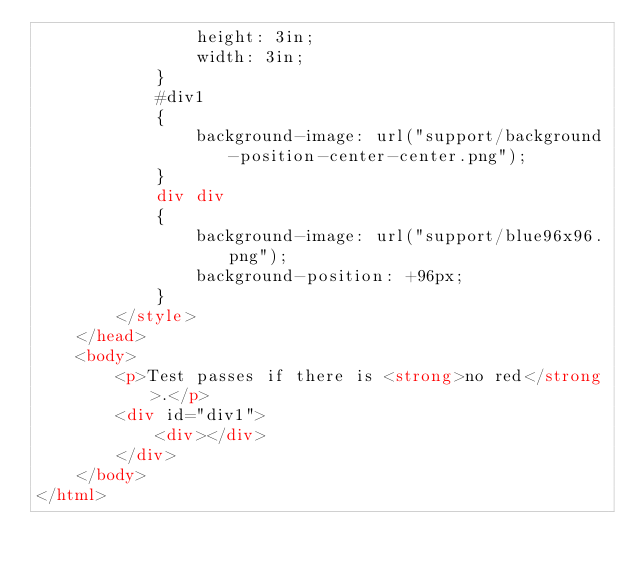<code> <loc_0><loc_0><loc_500><loc_500><_HTML_>                height: 3in;
                width: 3in;
            }
            #div1
            {
                background-image: url("support/background-position-center-center.png");
            }
            div div
            {
                background-image: url("support/blue96x96.png");
                background-position: +96px;
            }
        </style>
    </head>
    <body>
        <p>Test passes if there is <strong>no red</strong>.</p>
        <div id="div1">
            <div></div>
        </div>
    </body>
</html></code> 